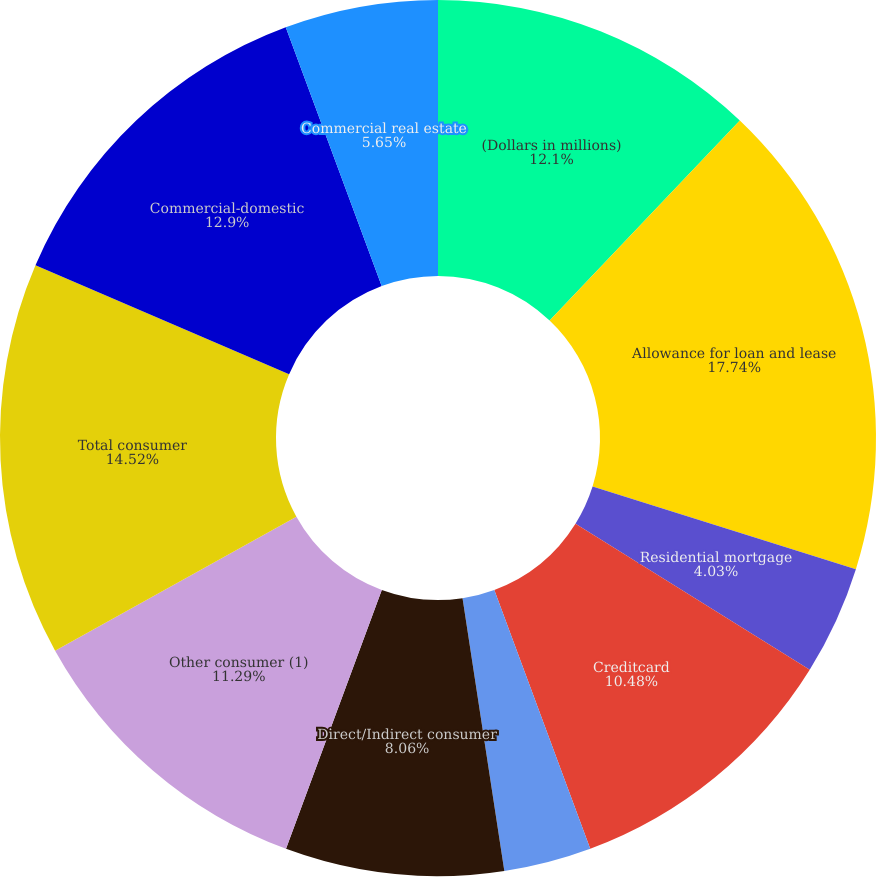Convert chart to OTSL. <chart><loc_0><loc_0><loc_500><loc_500><pie_chart><fcel>(Dollars in millions)<fcel>Allowance for loan and lease<fcel>Residential mortgage<fcel>Creditcard<fcel>Homeequitylines<fcel>Direct/Indirect consumer<fcel>Other consumer (1)<fcel>Total consumer<fcel>Commercial-domestic<fcel>Commercial real estate<nl><fcel>12.1%<fcel>17.74%<fcel>4.03%<fcel>10.48%<fcel>3.23%<fcel>8.06%<fcel>11.29%<fcel>14.52%<fcel>12.9%<fcel>5.65%<nl></chart> 